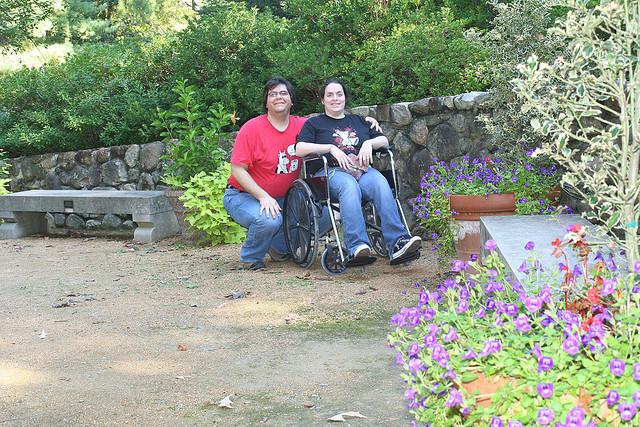Are the wheel locked on the chair?
Answer briefly. Yes. What kind of wall is behind them?
Quick response, please. Stone. Where is the woman looking?
Answer briefly. Camera. What color shirt is the boy wearing?
Concise answer only. Red. What kind of tall trees are in the background?
Short answer required. Shrubs. How many of these people are women?
Short answer required. 1. Where is the man sitting?
Short answer required. Wheelchair. Where is the person sitting?
Give a very brief answer. Wheelchair. What is the woman wearing?
Quick response, please. Jeans. How many planters are there?
Keep it brief. 2. Are the front or back wheels larger on the wheelchair?
Write a very short answer. Back. 